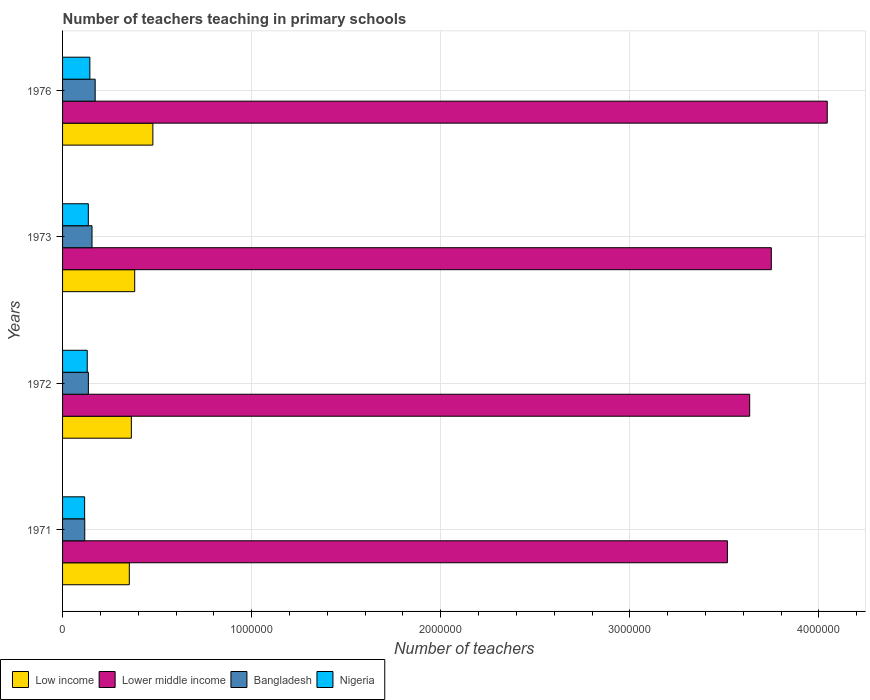Are the number of bars per tick equal to the number of legend labels?
Your response must be concise. Yes. Are the number of bars on each tick of the Y-axis equal?
Your answer should be compact. Yes. What is the label of the 3rd group of bars from the top?
Give a very brief answer. 1972. What is the number of teachers teaching in primary schools in Low income in 1972?
Provide a short and direct response. 3.64e+05. Across all years, what is the maximum number of teachers teaching in primary schools in Nigeria?
Offer a very short reply. 1.44e+05. Across all years, what is the minimum number of teachers teaching in primary schools in Low income?
Offer a terse response. 3.53e+05. In which year was the number of teachers teaching in primary schools in Bangladesh maximum?
Provide a succinct answer. 1976. What is the total number of teachers teaching in primary schools in Lower middle income in the graph?
Your answer should be compact. 1.49e+07. What is the difference between the number of teachers teaching in primary schools in Bangladesh in 1971 and that in 1972?
Your response must be concise. -1.92e+04. What is the difference between the number of teachers teaching in primary schools in Bangladesh in 1971 and the number of teachers teaching in primary schools in Lower middle income in 1976?
Offer a terse response. -3.93e+06. What is the average number of teachers teaching in primary schools in Lower middle income per year?
Provide a succinct answer. 3.74e+06. In the year 1971, what is the difference between the number of teachers teaching in primary schools in Bangladesh and number of teachers teaching in primary schools in Lower middle income?
Offer a terse response. -3.40e+06. What is the ratio of the number of teachers teaching in primary schools in Bangladesh in 1971 to that in 1972?
Ensure brevity in your answer.  0.86. Is the number of teachers teaching in primary schools in Bangladesh in 1971 less than that in 1976?
Your response must be concise. Yes. Is the difference between the number of teachers teaching in primary schools in Bangladesh in 1971 and 1972 greater than the difference between the number of teachers teaching in primary schools in Lower middle income in 1971 and 1972?
Give a very brief answer. Yes. What is the difference between the highest and the second highest number of teachers teaching in primary schools in Lower middle income?
Offer a terse response. 2.96e+05. What is the difference between the highest and the lowest number of teachers teaching in primary schools in Nigeria?
Offer a very short reply. 2.77e+04. Is the sum of the number of teachers teaching in primary schools in Bangladesh in 1971 and 1972 greater than the maximum number of teachers teaching in primary schools in Nigeria across all years?
Ensure brevity in your answer.  Yes. Is it the case that in every year, the sum of the number of teachers teaching in primary schools in Lower middle income and number of teachers teaching in primary schools in Nigeria is greater than the sum of number of teachers teaching in primary schools in Bangladesh and number of teachers teaching in primary schools in Low income?
Offer a terse response. No. What does the 2nd bar from the top in 1976 represents?
Your answer should be very brief. Bangladesh. What does the 3rd bar from the bottom in 1976 represents?
Make the answer very short. Bangladesh. Is it the case that in every year, the sum of the number of teachers teaching in primary schools in Low income and number of teachers teaching in primary schools in Lower middle income is greater than the number of teachers teaching in primary schools in Nigeria?
Give a very brief answer. Yes. How many bars are there?
Provide a succinct answer. 16. Are all the bars in the graph horizontal?
Your answer should be very brief. Yes. How many years are there in the graph?
Keep it short and to the point. 4. Does the graph contain any zero values?
Keep it short and to the point. No. Does the graph contain grids?
Ensure brevity in your answer.  Yes. How many legend labels are there?
Your response must be concise. 4. What is the title of the graph?
Your response must be concise. Number of teachers teaching in primary schools. Does "Low & middle income" appear as one of the legend labels in the graph?
Your answer should be very brief. No. What is the label or title of the X-axis?
Offer a terse response. Number of teachers. What is the Number of teachers of Low income in 1971?
Keep it short and to the point. 3.53e+05. What is the Number of teachers in Lower middle income in 1971?
Provide a short and direct response. 3.52e+06. What is the Number of teachers of Bangladesh in 1971?
Ensure brevity in your answer.  1.17e+05. What is the Number of teachers in Nigeria in 1971?
Your response must be concise. 1.17e+05. What is the Number of teachers of Low income in 1972?
Ensure brevity in your answer.  3.64e+05. What is the Number of teachers in Lower middle income in 1972?
Your answer should be compact. 3.63e+06. What is the Number of teachers of Bangladesh in 1972?
Your answer should be compact. 1.37e+05. What is the Number of teachers of Nigeria in 1972?
Your answer should be very brief. 1.30e+05. What is the Number of teachers of Low income in 1973?
Offer a very short reply. 3.81e+05. What is the Number of teachers in Lower middle income in 1973?
Offer a very short reply. 3.75e+06. What is the Number of teachers of Bangladesh in 1973?
Your answer should be very brief. 1.56e+05. What is the Number of teachers in Nigeria in 1973?
Offer a very short reply. 1.36e+05. What is the Number of teachers of Low income in 1976?
Provide a succinct answer. 4.78e+05. What is the Number of teachers of Lower middle income in 1976?
Provide a succinct answer. 4.04e+06. What is the Number of teachers of Bangladesh in 1976?
Ensure brevity in your answer.  1.72e+05. What is the Number of teachers of Nigeria in 1976?
Ensure brevity in your answer.  1.44e+05. Across all years, what is the maximum Number of teachers in Low income?
Make the answer very short. 4.78e+05. Across all years, what is the maximum Number of teachers of Lower middle income?
Provide a short and direct response. 4.04e+06. Across all years, what is the maximum Number of teachers of Bangladesh?
Offer a terse response. 1.72e+05. Across all years, what is the maximum Number of teachers in Nigeria?
Make the answer very short. 1.44e+05. Across all years, what is the minimum Number of teachers in Low income?
Make the answer very short. 3.53e+05. Across all years, what is the minimum Number of teachers in Lower middle income?
Keep it short and to the point. 3.52e+06. Across all years, what is the minimum Number of teachers in Bangladesh?
Keep it short and to the point. 1.17e+05. Across all years, what is the minimum Number of teachers in Nigeria?
Give a very brief answer. 1.17e+05. What is the total Number of teachers of Low income in the graph?
Provide a short and direct response. 1.58e+06. What is the total Number of teachers of Lower middle income in the graph?
Your answer should be very brief. 1.49e+07. What is the total Number of teachers in Bangladesh in the graph?
Provide a succinct answer. 5.82e+05. What is the total Number of teachers of Nigeria in the graph?
Make the answer very short. 5.28e+05. What is the difference between the Number of teachers in Low income in 1971 and that in 1972?
Offer a terse response. -1.08e+04. What is the difference between the Number of teachers of Lower middle income in 1971 and that in 1972?
Provide a short and direct response. -1.18e+05. What is the difference between the Number of teachers in Bangladesh in 1971 and that in 1972?
Ensure brevity in your answer.  -1.92e+04. What is the difference between the Number of teachers in Nigeria in 1971 and that in 1972?
Ensure brevity in your answer.  -1.38e+04. What is the difference between the Number of teachers in Low income in 1971 and that in 1973?
Give a very brief answer. -2.85e+04. What is the difference between the Number of teachers in Lower middle income in 1971 and that in 1973?
Your answer should be compact. -2.32e+05. What is the difference between the Number of teachers in Bangladesh in 1971 and that in 1973?
Your response must be concise. -3.85e+04. What is the difference between the Number of teachers of Nigeria in 1971 and that in 1973?
Your response must be concise. -1.95e+04. What is the difference between the Number of teachers of Low income in 1971 and that in 1976?
Make the answer very short. -1.25e+05. What is the difference between the Number of teachers in Lower middle income in 1971 and that in 1976?
Offer a terse response. -5.28e+05. What is the difference between the Number of teachers in Bangladesh in 1971 and that in 1976?
Your response must be concise. -5.52e+04. What is the difference between the Number of teachers of Nigeria in 1971 and that in 1976?
Give a very brief answer. -2.77e+04. What is the difference between the Number of teachers of Low income in 1972 and that in 1973?
Your answer should be compact. -1.77e+04. What is the difference between the Number of teachers of Lower middle income in 1972 and that in 1973?
Ensure brevity in your answer.  -1.14e+05. What is the difference between the Number of teachers of Bangladesh in 1972 and that in 1973?
Keep it short and to the point. -1.92e+04. What is the difference between the Number of teachers in Nigeria in 1972 and that in 1973?
Offer a terse response. -5708. What is the difference between the Number of teachers in Low income in 1972 and that in 1976?
Ensure brevity in your answer.  -1.14e+05. What is the difference between the Number of teachers in Lower middle income in 1972 and that in 1976?
Provide a succinct answer. -4.10e+05. What is the difference between the Number of teachers in Bangladesh in 1972 and that in 1976?
Offer a very short reply. -3.59e+04. What is the difference between the Number of teachers of Nigeria in 1972 and that in 1976?
Keep it short and to the point. -1.39e+04. What is the difference between the Number of teachers in Low income in 1973 and that in 1976?
Provide a succinct answer. -9.61e+04. What is the difference between the Number of teachers of Lower middle income in 1973 and that in 1976?
Your answer should be very brief. -2.96e+05. What is the difference between the Number of teachers in Bangladesh in 1973 and that in 1976?
Your answer should be compact. -1.67e+04. What is the difference between the Number of teachers of Nigeria in 1973 and that in 1976?
Ensure brevity in your answer.  -8209. What is the difference between the Number of teachers of Low income in 1971 and the Number of teachers of Lower middle income in 1972?
Provide a succinct answer. -3.28e+06. What is the difference between the Number of teachers in Low income in 1971 and the Number of teachers in Bangladesh in 1972?
Your answer should be compact. 2.16e+05. What is the difference between the Number of teachers of Low income in 1971 and the Number of teachers of Nigeria in 1972?
Keep it short and to the point. 2.23e+05. What is the difference between the Number of teachers in Lower middle income in 1971 and the Number of teachers in Bangladesh in 1972?
Keep it short and to the point. 3.38e+06. What is the difference between the Number of teachers of Lower middle income in 1971 and the Number of teachers of Nigeria in 1972?
Ensure brevity in your answer.  3.39e+06. What is the difference between the Number of teachers of Bangladesh in 1971 and the Number of teachers of Nigeria in 1972?
Keep it short and to the point. -1.32e+04. What is the difference between the Number of teachers of Low income in 1971 and the Number of teachers of Lower middle income in 1973?
Provide a succinct answer. -3.39e+06. What is the difference between the Number of teachers of Low income in 1971 and the Number of teachers of Bangladesh in 1973?
Offer a very short reply. 1.97e+05. What is the difference between the Number of teachers of Low income in 1971 and the Number of teachers of Nigeria in 1973?
Provide a succinct answer. 2.17e+05. What is the difference between the Number of teachers in Lower middle income in 1971 and the Number of teachers in Bangladesh in 1973?
Give a very brief answer. 3.36e+06. What is the difference between the Number of teachers in Lower middle income in 1971 and the Number of teachers in Nigeria in 1973?
Your answer should be compact. 3.38e+06. What is the difference between the Number of teachers in Bangladesh in 1971 and the Number of teachers in Nigeria in 1973?
Ensure brevity in your answer.  -1.89e+04. What is the difference between the Number of teachers of Low income in 1971 and the Number of teachers of Lower middle income in 1976?
Make the answer very short. -3.69e+06. What is the difference between the Number of teachers in Low income in 1971 and the Number of teachers in Bangladesh in 1976?
Provide a succinct answer. 1.81e+05. What is the difference between the Number of teachers of Low income in 1971 and the Number of teachers of Nigeria in 1976?
Provide a succinct answer. 2.09e+05. What is the difference between the Number of teachers in Lower middle income in 1971 and the Number of teachers in Bangladesh in 1976?
Ensure brevity in your answer.  3.34e+06. What is the difference between the Number of teachers in Lower middle income in 1971 and the Number of teachers in Nigeria in 1976?
Give a very brief answer. 3.37e+06. What is the difference between the Number of teachers of Bangladesh in 1971 and the Number of teachers of Nigeria in 1976?
Offer a very short reply. -2.71e+04. What is the difference between the Number of teachers in Low income in 1972 and the Number of teachers in Lower middle income in 1973?
Offer a very short reply. -3.38e+06. What is the difference between the Number of teachers of Low income in 1972 and the Number of teachers of Bangladesh in 1973?
Your response must be concise. 2.08e+05. What is the difference between the Number of teachers of Low income in 1972 and the Number of teachers of Nigeria in 1973?
Offer a terse response. 2.28e+05. What is the difference between the Number of teachers in Lower middle income in 1972 and the Number of teachers in Bangladesh in 1973?
Make the answer very short. 3.48e+06. What is the difference between the Number of teachers of Lower middle income in 1972 and the Number of teachers of Nigeria in 1973?
Make the answer very short. 3.50e+06. What is the difference between the Number of teachers of Bangladesh in 1972 and the Number of teachers of Nigeria in 1973?
Offer a terse response. 366. What is the difference between the Number of teachers in Low income in 1972 and the Number of teachers in Lower middle income in 1976?
Offer a very short reply. -3.68e+06. What is the difference between the Number of teachers in Low income in 1972 and the Number of teachers in Bangladesh in 1976?
Keep it short and to the point. 1.91e+05. What is the difference between the Number of teachers in Low income in 1972 and the Number of teachers in Nigeria in 1976?
Your answer should be compact. 2.19e+05. What is the difference between the Number of teachers of Lower middle income in 1972 and the Number of teachers of Bangladesh in 1976?
Your answer should be very brief. 3.46e+06. What is the difference between the Number of teachers of Lower middle income in 1972 and the Number of teachers of Nigeria in 1976?
Provide a succinct answer. 3.49e+06. What is the difference between the Number of teachers of Bangladesh in 1972 and the Number of teachers of Nigeria in 1976?
Provide a succinct answer. -7843. What is the difference between the Number of teachers of Low income in 1973 and the Number of teachers of Lower middle income in 1976?
Provide a short and direct response. -3.66e+06. What is the difference between the Number of teachers of Low income in 1973 and the Number of teachers of Bangladesh in 1976?
Offer a terse response. 2.09e+05. What is the difference between the Number of teachers in Low income in 1973 and the Number of teachers in Nigeria in 1976?
Ensure brevity in your answer.  2.37e+05. What is the difference between the Number of teachers in Lower middle income in 1973 and the Number of teachers in Bangladesh in 1976?
Offer a very short reply. 3.58e+06. What is the difference between the Number of teachers of Lower middle income in 1973 and the Number of teachers of Nigeria in 1976?
Provide a short and direct response. 3.60e+06. What is the difference between the Number of teachers of Bangladesh in 1973 and the Number of teachers of Nigeria in 1976?
Offer a very short reply. 1.14e+04. What is the average Number of teachers in Low income per year?
Your response must be concise. 3.94e+05. What is the average Number of teachers in Lower middle income per year?
Offer a very short reply. 3.74e+06. What is the average Number of teachers in Bangladesh per year?
Provide a succinct answer. 1.45e+05. What is the average Number of teachers of Nigeria per year?
Give a very brief answer. 1.32e+05. In the year 1971, what is the difference between the Number of teachers in Low income and Number of teachers in Lower middle income?
Provide a short and direct response. -3.16e+06. In the year 1971, what is the difference between the Number of teachers in Low income and Number of teachers in Bangladesh?
Provide a succinct answer. 2.36e+05. In the year 1971, what is the difference between the Number of teachers in Low income and Number of teachers in Nigeria?
Provide a short and direct response. 2.36e+05. In the year 1971, what is the difference between the Number of teachers of Lower middle income and Number of teachers of Bangladesh?
Your response must be concise. 3.40e+06. In the year 1971, what is the difference between the Number of teachers in Lower middle income and Number of teachers in Nigeria?
Keep it short and to the point. 3.40e+06. In the year 1971, what is the difference between the Number of teachers in Bangladesh and Number of teachers in Nigeria?
Your answer should be very brief. 635. In the year 1972, what is the difference between the Number of teachers of Low income and Number of teachers of Lower middle income?
Give a very brief answer. -3.27e+06. In the year 1972, what is the difference between the Number of teachers of Low income and Number of teachers of Bangladesh?
Your response must be concise. 2.27e+05. In the year 1972, what is the difference between the Number of teachers of Low income and Number of teachers of Nigeria?
Make the answer very short. 2.33e+05. In the year 1972, what is the difference between the Number of teachers in Lower middle income and Number of teachers in Bangladesh?
Your answer should be very brief. 3.50e+06. In the year 1972, what is the difference between the Number of teachers in Lower middle income and Number of teachers in Nigeria?
Offer a terse response. 3.50e+06. In the year 1972, what is the difference between the Number of teachers in Bangladesh and Number of teachers in Nigeria?
Offer a very short reply. 6074. In the year 1973, what is the difference between the Number of teachers of Low income and Number of teachers of Lower middle income?
Give a very brief answer. -3.37e+06. In the year 1973, what is the difference between the Number of teachers of Low income and Number of teachers of Bangladesh?
Ensure brevity in your answer.  2.26e+05. In the year 1973, what is the difference between the Number of teachers in Low income and Number of teachers in Nigeria?
Offer a terse response. 2.45e+05. In the year 1973, what is the difference between the Number of teachers of Lower middle income and Number of teachers of Bangladesh?
Ensure brevity in your answer.  3.59e+06. In the year 1973, what is the difference between the Number of teachers of Lower middle income and Number of teachers of Nigeria?
Make the answer very short. 3.61e+06. In the year 1973, what is the difference between the Number of teachers of Bangladesh and Number of teachers of Nigeria?
Provide a short and direct response. 1.96e+04. In the year 1976, what is the difference between the Number of teachers in Low income and Number of teachers in Lower middle income?
Offer a very short reply. -3.57e+06. In the year 1976, what is the difference between the Number of teachers in Low income and Number of teachers in Bangladesh?
Provide a short and direct response. 3.05e+05. In the year 1976, what is the difference between the Number of teachers of Low income and Number of teachers of Nigeria?
Offer a terse response. 3.33e+05. In the year 1976, what is the difference between the Number of teachers of Lower middle income and Number of teachers of Bangladesh?
Your answer should be compact. 3.87e+06. In the year 1976, what is the difference between the Number of teachers of Lower middle income and Number of teachers of Nigeria?
Provide a succinct answer. 3.90e+06. In the year 1976, what is the difference between the Number of teachers of Bangladesh and Number of teachers of Nigeria?
Offer a very short reply. 2.81e+04. What is the ratio of the Number of teachers in Low income in 1971 to that in 1972?
Provide a succinct answer. 0.97. What is the ratio of the Number of teachers of Lower middle income in 1971 to that in 1972?
Provide a succinct answer. 0.97. What is the ratio of the Number of teachers in Bangladesh in 1971 to that in 1972?
Make the answer very short. 0.86. What is the ratio of the Number of teachers in Nigeria in 1971 to that in 1972?
Make the answer very short. 0.89. What is the ratio of the Number of teachers in Low income in 1971 to that in 1973?
Your answer should be very brief. 0.93. What is the ratio of the Number of teachers of Lower middle income in 1971 to that in 1973?
Your answer should be very brief. 0.94. What is the ratio of the Number of teachers in Bangladesh in 1971 to that in 1973?
Make the answer very short. 0.75. What is the ratio of the Number of teachers in Nigeria in 1971 to that in 1973?
Offer a very short reply. 0.86. What is the ratio of the Number of teachers in Low income in 1971 to that in 1976?
Provide a short and direct response. 0.74. What is the ratio of the Number of teachers in Lower middle income in 1971 to that in 1976?
Keep it short and to the point. 0.87. What is the ratio of the Number of teachers in Bangladesh in 1971 to that in 1976?
Give a very brief answer. 0.68. What is the ratio of the Number of teachers of Nigeria in 1971 to that in 1976?
Give a very brief answer. 0.81. What is the ratio of the Number of teachers of Low income in 1972 to that in 1973?
Provide a succinct answer. 0.95. What is the ratio of the Number of teachers in Lower middle income in 1972 to that in 1973?
Give a very brief answer. 0.97. What is the ratio of the Number of teachers in Bangladesh in 1972 to that in 1973?
Your answer should be very brief. 0.88. What is the ratio of the Number of teachers in Nigeria in 1972 to that in 1973?
Your response must be concise. 0.96. What is the ratio of the Number of teachers in Low income in 1972 to that in 1976?
Your answer should be compact. 0.76. What is the ratio of the Number of teachers in Lower middle income in 1972 to that in 1976?
Your answer should be very brief. 0.9. What is the ratio of the Number of teachers in Bangladesh in 1972 to that in 1976?
Your answer should be compact. 0.79. What is the ratio of the Number of teachers in Nigeria in 1972 to that in 1976?
Offer a terse response. 0.9. What is the ratio of the Number of teachers of Low income in 1973 to that in 1976?
Keep it short and to the point. 0.8. What is the ratio of the Number of teachers in Lower middle income in 1973 to that in 1976?
Offer a terse response. 0.93. What is the ratio of the Number of teachers of Bangladesh in 1973 to that in 1976?
Provide a succinct answer. 0.9. What is the ratio of the Number of teachers in Nigeria in 1973 to that in 1976?
Make the answer very short. 0.94. What is the difference between the highest and the second highest Number of teachers of Low income?
Offer a very short reply. 9.61e+04. What is the difference between the highest and the second highest Number of teachers of Lower middle income?
Give a very brief answer. 2.96e+05. What is the difference between the highest and the second highest Number of teachers of Bangladesh?
Give a very brief answer. 1.67e+04. What is the difference between the highest and the second highest Number of teachers in Nigeria?
Offer a very short reply. 8209. What is the difference between the highest and the lowest Number of teachers in Low income?
Provide a succinct answer. 1.25e+05. What is the difference between the highest and the lowest Number of teachers of Lower middle income?
Make the answer very short. 5.28e+05. What is the difference between the highest and the lowest Number of teachers of Bangladesh?
Give a very brief answer. 5.52e+04. What is the difference between the highest and the lowest Number of teachers of Nigeria?
Make the answer very short. 2.77e+04. 